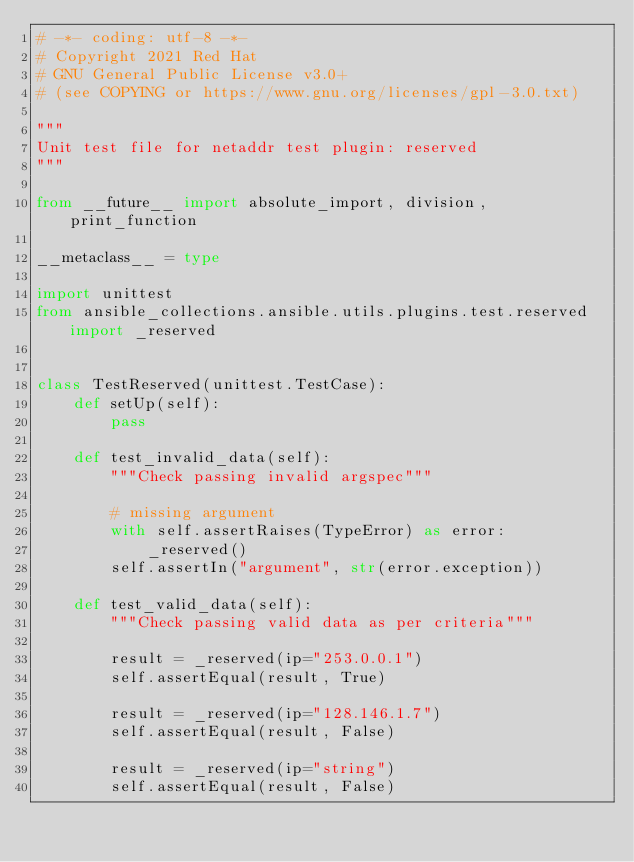Convert code to text. <code><loc_0><loc_0><loc_500><loc_500><_Python_># -*- coding: utf-8 -*-
# Copyright 2021 Red Hat
# GNU General Public License v3.0+
# (see COPYING or https://www.gnu.org/licenses/gpl-3.0.txt)

"""
Unit test file for netaddr test plugin: reserved
"""

from __future__ import absolute_import, division, print_function

__metaclass__ = type

import unittest
from ansible_collections.ansible.utils.plugins.test.reserved import _reserved


class TestReserved(unittest.TestCase):
    def setUp(self):
        pass

    def test_invalid_data(self):
        """Check passing invalid argspec"""

        # missing argument
        with self.assertRaises(TypeError) as error:
            _reserved()
        self.assertIn("argument", str(error.exception))

    def test_valid_data(self):
        """Check passing valid data as per criteria"""

        result = _reserved(ip="253.0.0.1")
        self.assertEqual(result, True)

        result = _reserved(ip="128.146.1.7")
        self.assertEqual(result, False)

        result = _reserved(ip="string")
        self.assertEqual(result, False)
</code> 